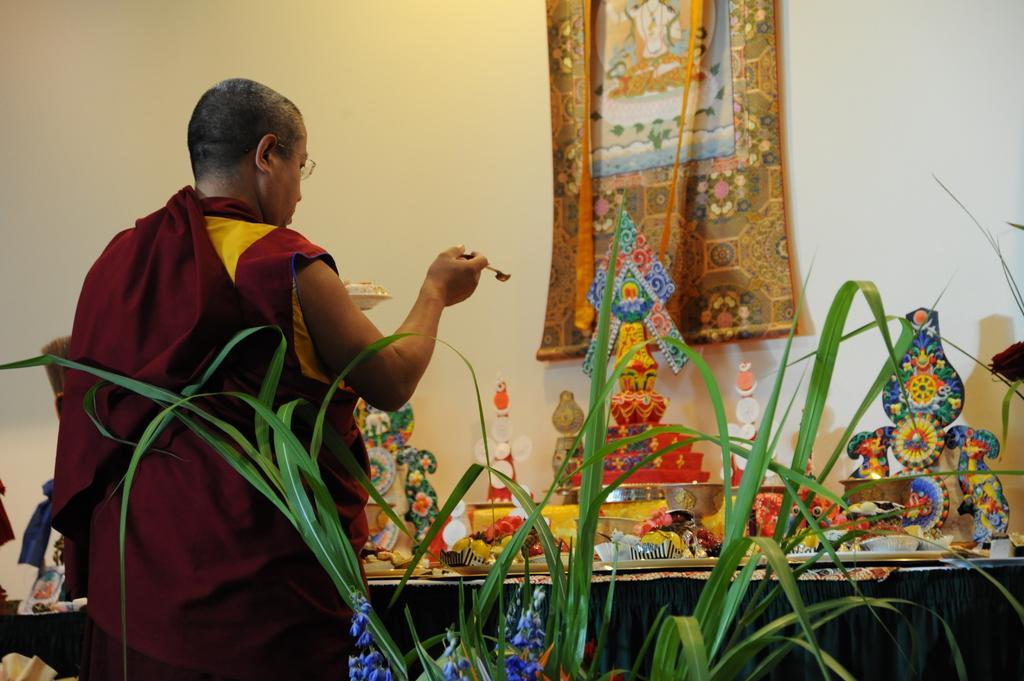Please provide a concise description of this image. On the left side, there is a person in red color dress, holding an object with one hand and standing. Beside him, there is a plant having green color leaves. In the background, there are statues and other objects on the table. Above this table, there is a photo frame attached to the white wall. 